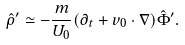Convert formula to latex. <formula><loc_0><loc_0><loc_500><loc_500>\hat { \rho } ^ { \prime } \simeq - \frac { m } { U _ { 0 } } ( \partial _ { t } + { v } _ { 0 } \cdot \nabla ) \hat { \Phi } ^ { \prime } .</formula> 